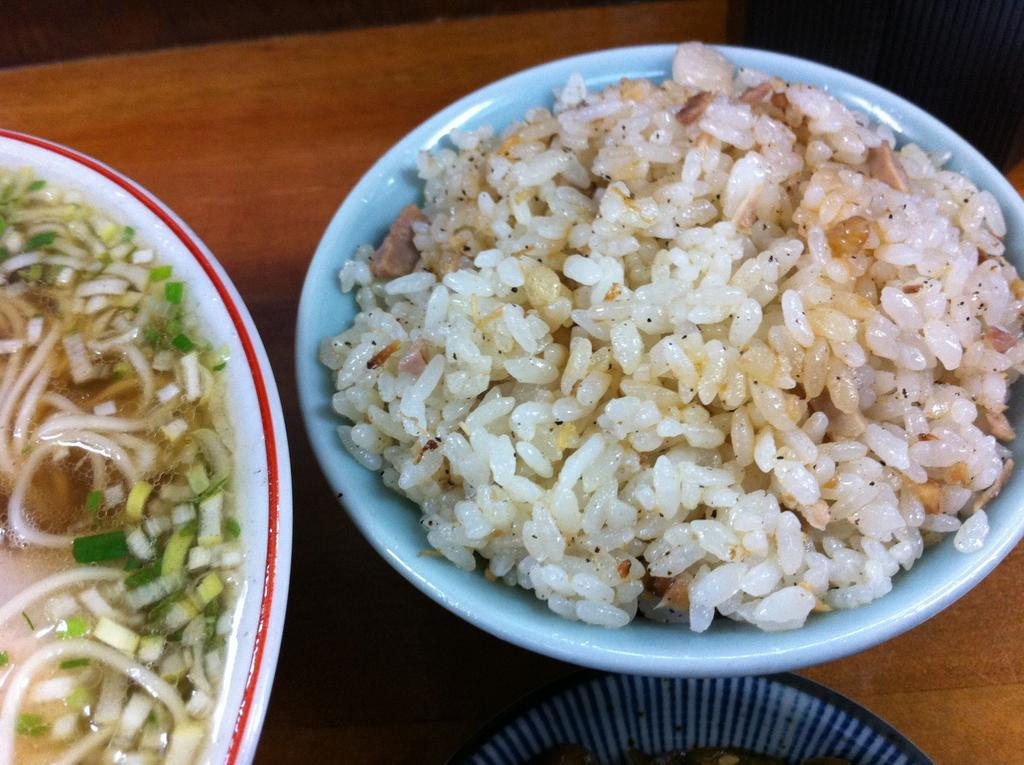What is present on the wooden surface in the image? There is a plate and a bowl on the wooden surface in the image. What is inside the bowl? There is rice in the bowl. What is on the plate? There is a food item on the plate. Can you see a kitty playing with an ant on the wooden surface in the image? No, there is no kitty or ant present on the wooden surface in the image. Is there a school visible in the image? No, there is no school present in the image. 